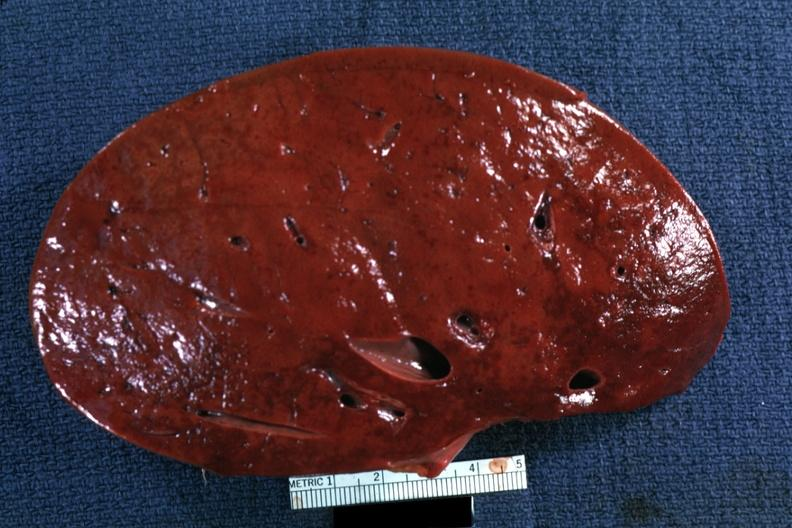s hematologic present?
Answer the question using a single word or phrase. Yes 